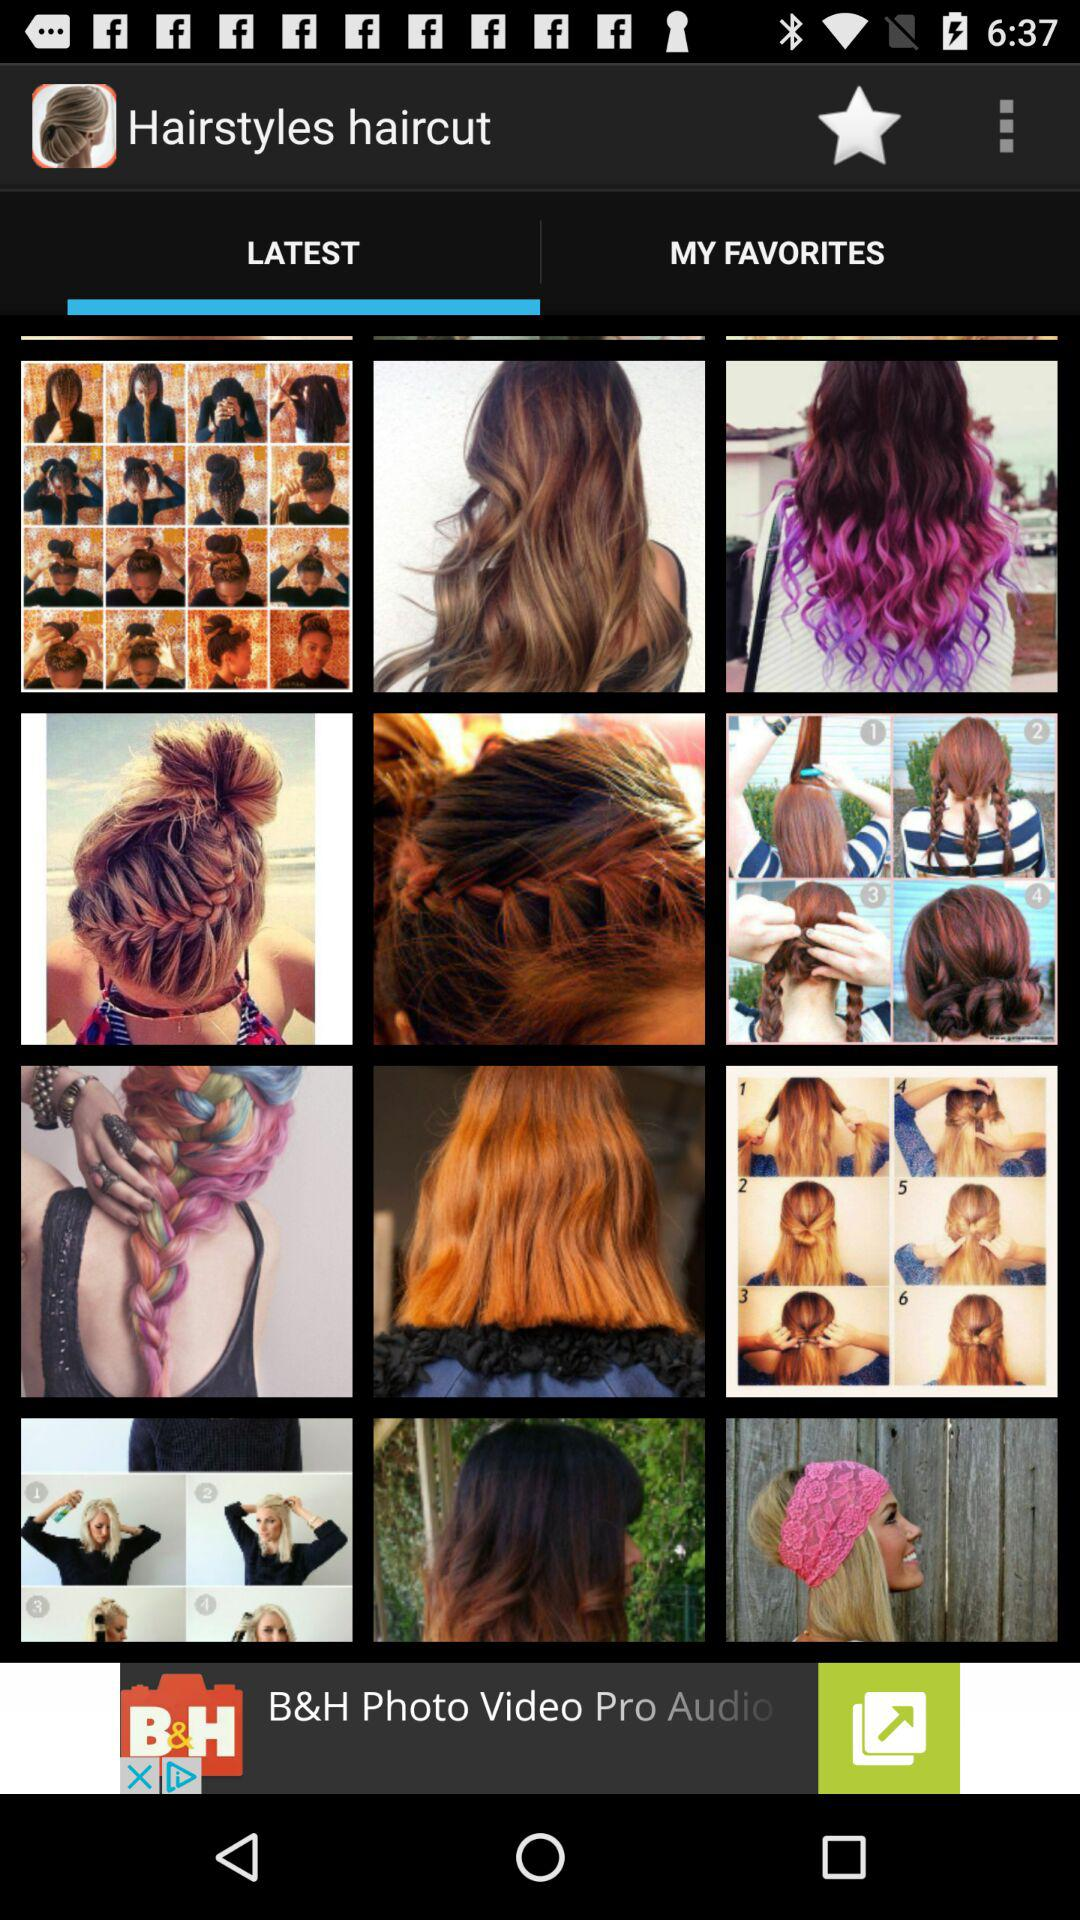Which tab is selected? The selected tab is "LATEST". 